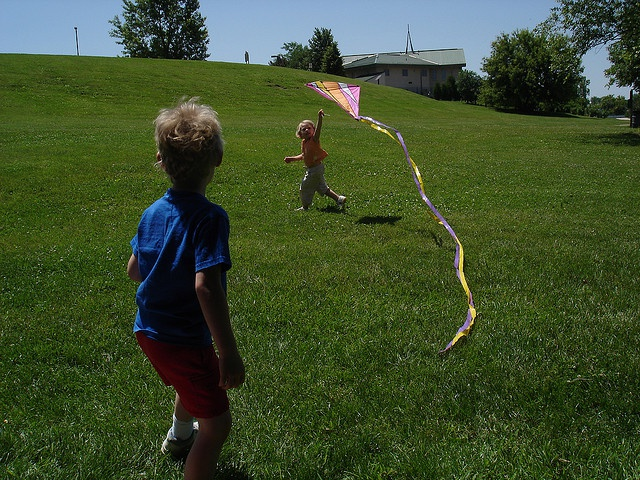Describe the objects in this image and their specific colors. I can see people in darkgray, black, navy, darkgreen, and blue tones, kite in darkgray, darkgreen, violet, gray, and khaki tones, people in darkgray, black, darkgreen, and maroon tones, and people in darkgray, black, gray, and purple tones in this image. 